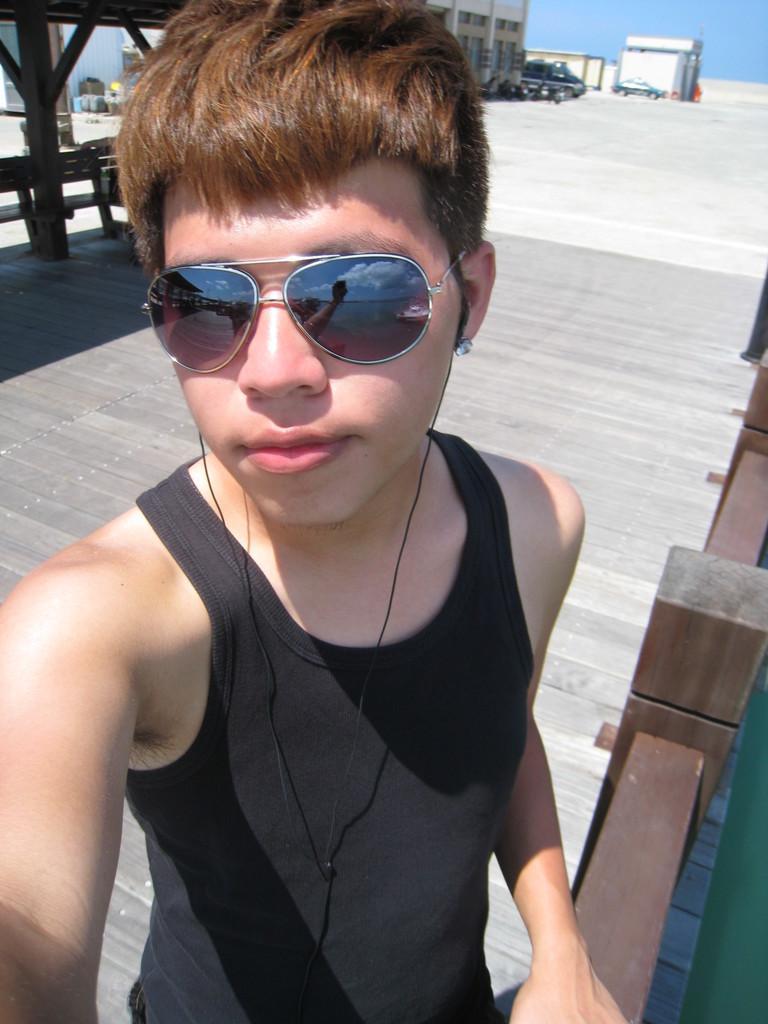Can you describe this image briefly? There is one boy standing and wearing goggles as we can see in the middle of this image. We can see buildings at the top of this image and the sky is in the background. 